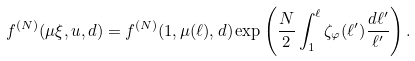<formula> <loc_0><loc_0><loc_500><loc_500>f ^ { ( N ) } ( \mu \xi , u , d ) = f ^ { ( N ) } ( 1 , \mu ( \ell ) , d ) \exp \left ( \frac { N } { 2 } \int _ { 1 } ^ { \ell } \zeta _ { \varphi } ( \ell ^ { \prime } ) \frac { d \ell ^ { \prime } } { \ell ^ { \prime } } \right ) .</formula> 